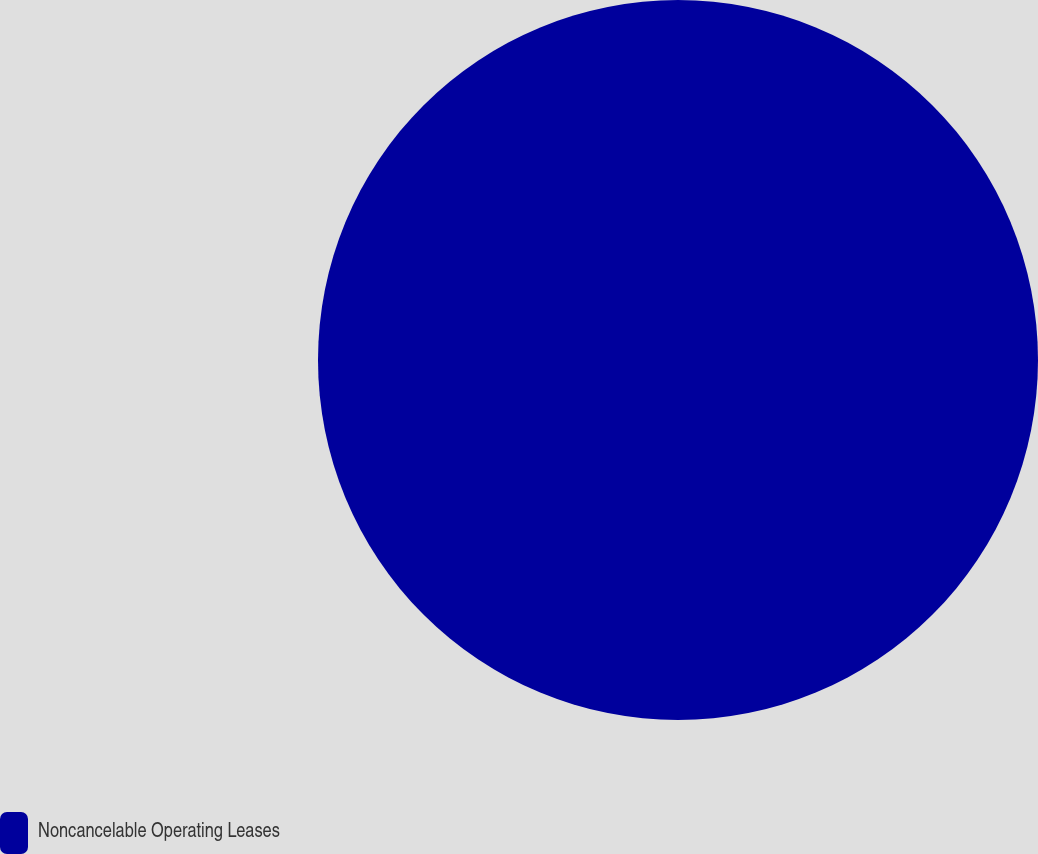Convert chart. <chart><loc_0><loc_0><loc_500><loc_500><pie_chart><fcel>Noncancelable Operating Leases<nl><fcel>100.0%<nl></chart> 